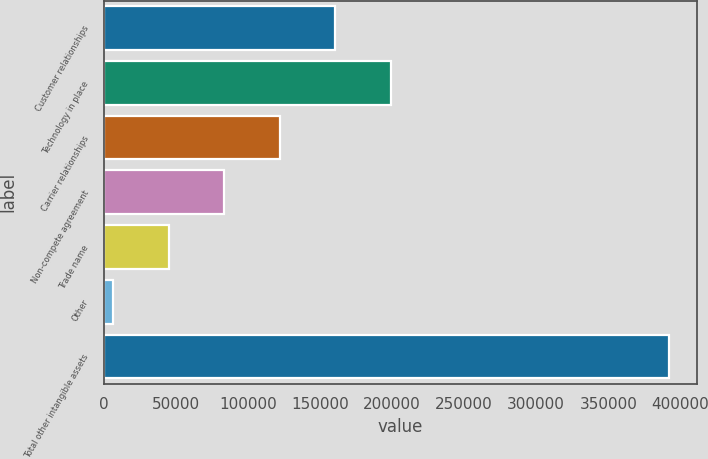<chart> <loc_0><loc_0><loc_500><loc_500><bar_chart><fcel>Customer relationships<fcel>Technology in place<fcel>Carrier relationships<fcel>Non-compete agreement<fcel>Trade name<fcel>Other<fcel>Total other intangible assets<nl><fcel>160765<fcel>199302<fcel>122229<fcel>83692.2<fcel>45155.6<fcel>6619<fcel>391985<nl></chart> 